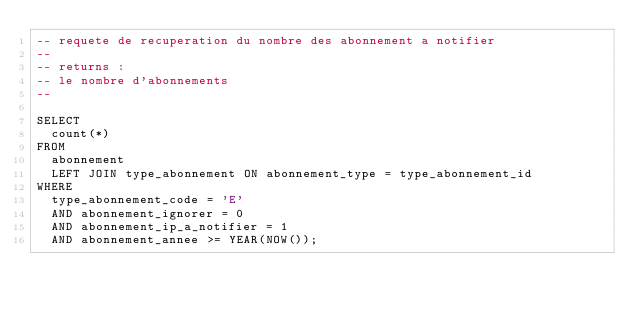<code> <loc_0><loc_0><loc_500><loc_500><_SQL_>-- requete de recuperation du nombre des abonnement a notifier
--
-- returns :
-- le nombre d'abonnements
--

SELECT
  count(*)
FROM
  abonnement
  LEFT JOIN type_abonnement ON abonnement_type = type_abonnement_id
WHERE
  type_abonnement_code = 'E'
  AND abonnement_ignorer = 0
  AND abonnement_ip_a_notifier = 1
  AND abonnement_annee >= YEAR(NOW());
</code> 